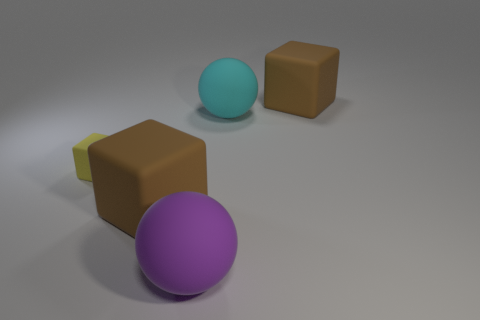Subtract all yellow balls. Subtract all cyan cylinders. How many balls are left? 2 Add 1 yellow matte things. How many objects exist? 6 Subtract all blocks. How many objects are left? 2 Add 3 big rubber blocks. How many big rubber blocks are left? 5 Add 2 big cyan matte balls. How many big cyan matte balls exist? 3 Subtract 0 green cylinders. How many objects are left? 5 Subtract all yellow objects. Subtract all green rubber cylinders. How many objects are left? 4 